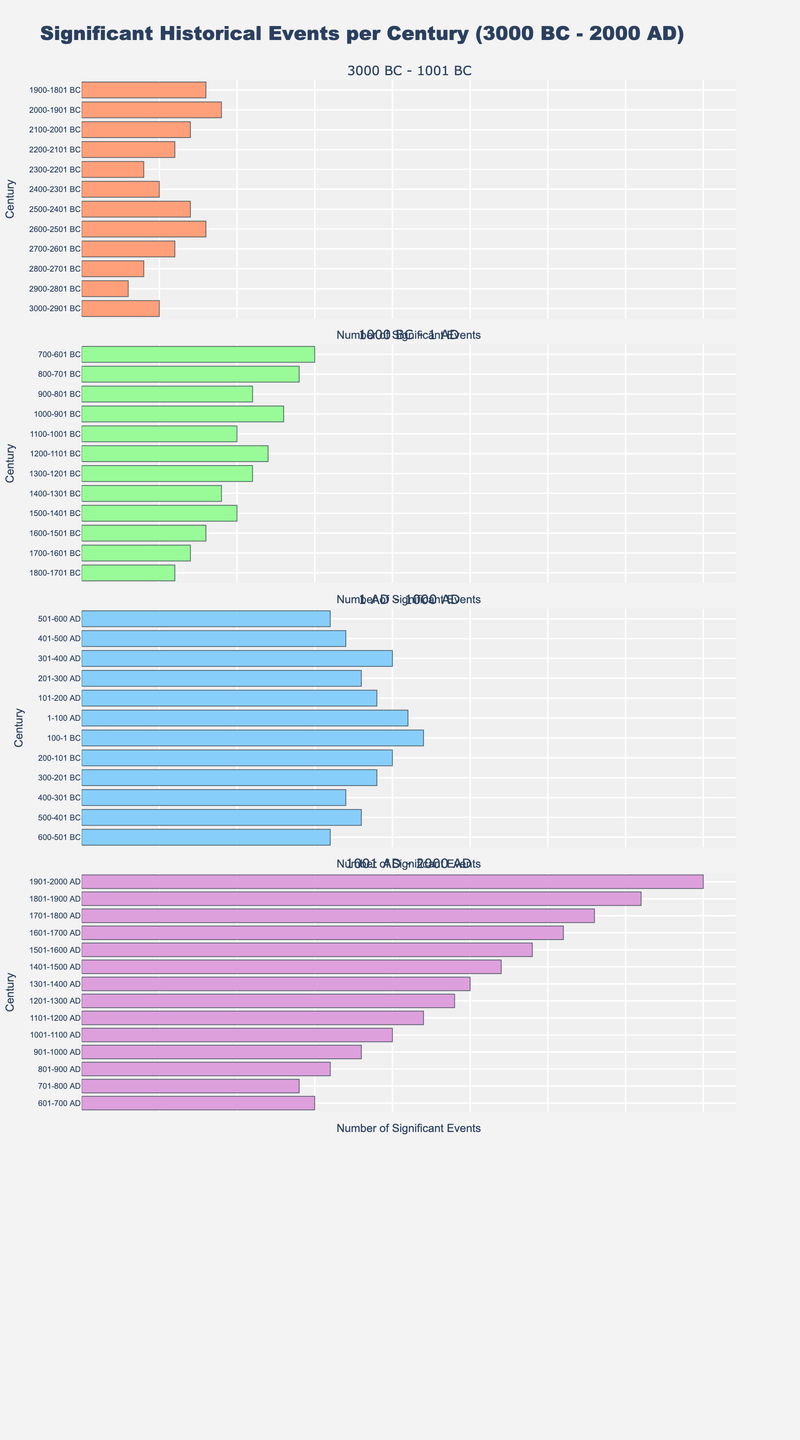How many subplots are shown in the figure? The figure contains four distinct segments representing different periods, and these segments are visually separated, thus indicating four subplots in total.
Answer: Four What colors are used to differentiate the subplots? By observing the different colors used in each of the subplots, we can identify four colors: light salmon, light green, light blue, and light purple.
Answer: Light salmon, light green, light blue, light purple Which century has the highest number of significant events in the fourth subplot (1001 AD - 2000 AD)? In the fourth subplot (1001 AD - 2000 AD), the century with the highest number of significant events appears to be 1901-2000 AD, with a count of 40 events.
Answer: 1901-2000 AD What is the trend in the number of significant events from 3000 BC - 1 AD? By analyzing the first two subplots, there is a general increasing trend in the number of significant events starting from 5 in 3000-2901 BC and reaching 22 in 100-1 BC.
Answer: Increasing How many centuries have more than 20 significant events? From the visual provided, count the number of bars that exceed the '20' mark across all subplots. The centuries which satisfy this condition are: 100-1 BC, 1-100 AD, 301-400 AD, 1101-1200 AD, 1201-1300 AD, 1301-1400 AD, 1401-1500 AD, 1501-1600 AD, 1601-1700 AD, 1701-1800 AD, 1801-1900 AD, and 1901-2000 AD. That's a total of 12 centuries.
Answer: 12 What is the range of the number of significant events for the centuries shown in the third subplot (1 AD - 1000 AD)? Find the minimum and maximum values in the third subplot (1 AD - 1000 AD). The number of significant events ranges from 14 (701-800 AD) to 24 (1201-1300 AD).
Answer: 14 to 24 Which subplot shows the most rapid increase in the number of significant events over time? By comparing the slopes of the bars in each subplot, the subplot from 1001 AD - 2000 AD shows the steepest increase from 16 events in 801-900 AD to 40 events in 1901-2000 AD.
Answer: Fourth subplot (1001 AD - 2000 AD) Compare the number of significant events in the century 300-201 BC to the century 100-1 BC. Which century had more events? Check the bar lengths for these two centuries. 300-201 BC has 19 events and 100-1 BC has 22 events. So, 100-1 BC had more significant events.
Answer: 100-1 BC What is the average number of significant events per century in the second subplot (1000 BC - 1 AD)? Add the number of events in each century shown in the second subplot and divide by the number of centuries. The total for 12 centuries is 21+13+11+14+15+16+18+17+19+20+22, which sums up to 208. The average is therefore, 208/11 = 18.91.
Answer: 18.91 